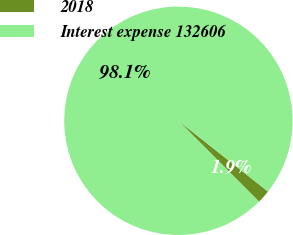<chart> <loc_0><loc_0><loc_500><loc_500><pie_chart><fcel>2018<fcel>Interest expense 132606<nl><fcel>1.88%<fcel>98.12%<nl></chart> 